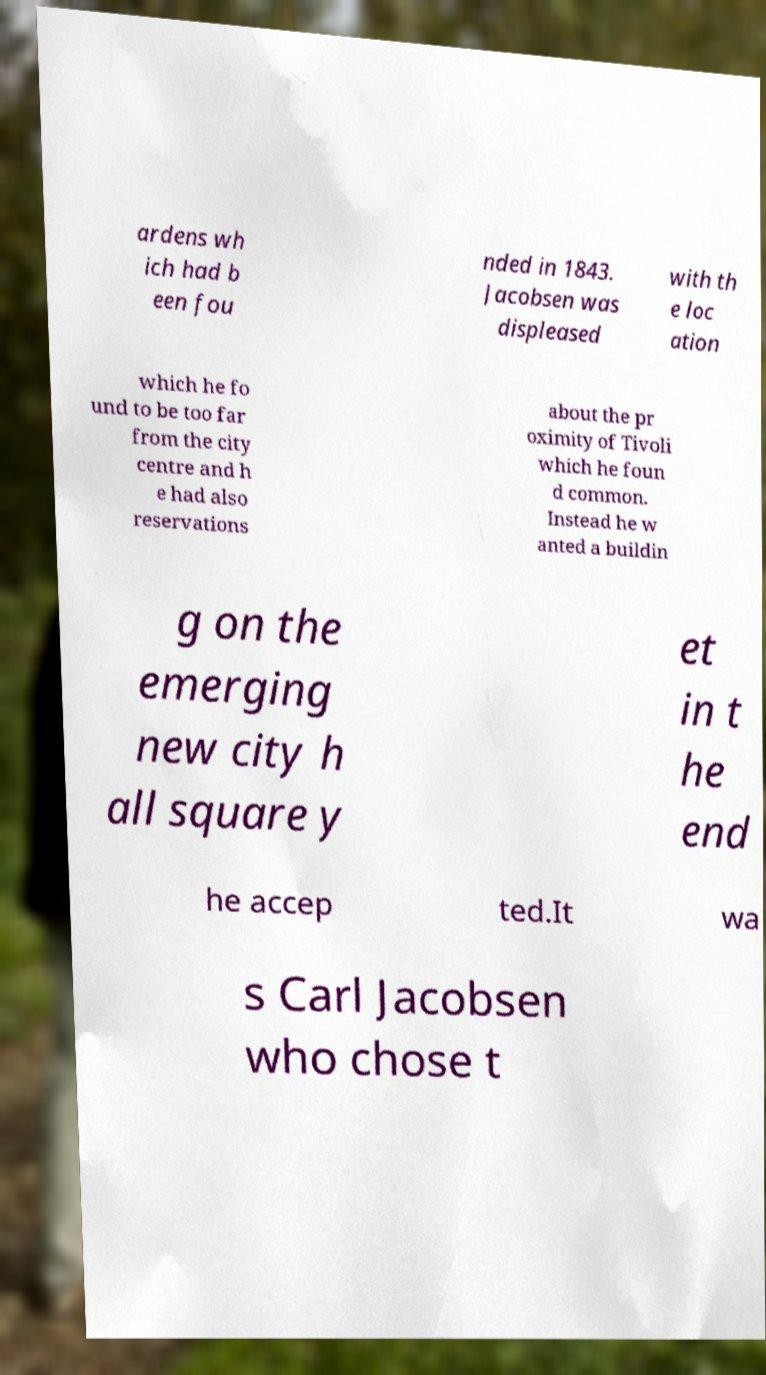Could you assist in decoding the text presented in this image and type it out clearly? ardens wh ich had b een fou nded in 1843. Jacobsen was displeased with th e loc ation which he fo und to be too far from the city centre and h e had also reservations about the pr oximity of Tivoli which he foun d common. Instead he w anted a buildin g on the emerging new city h all square y et in t he end he accep ted.It wa s Carl Jacobsen who chose t 